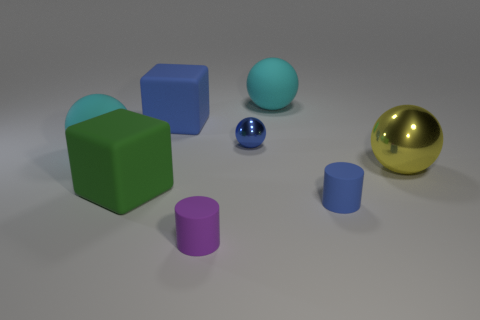Subtract all yellow shiny spheres. How many spheres are left? 3 Subtract all blue spheres. How many spheres are left? 3 Subtract 1 cylinders. How many cylinders are left? 1 Add 1 small objects. How many objects exist? 9 Subtract all blocks. How many objects are left? 6 Add 8 yellow matte blocks. How many yellow matte blocks exist? 8 Subtract 0 green cylinders. How many objects are left? 8 Subtract all green cubes. Subtract all brown cylinders. How many cubes are left? 1 Subtract all blue cubes. How many purple spheres are left? 0 Subtract all rubber cubes. Subtract all small blue metallic objects. How many objects are left? 5 